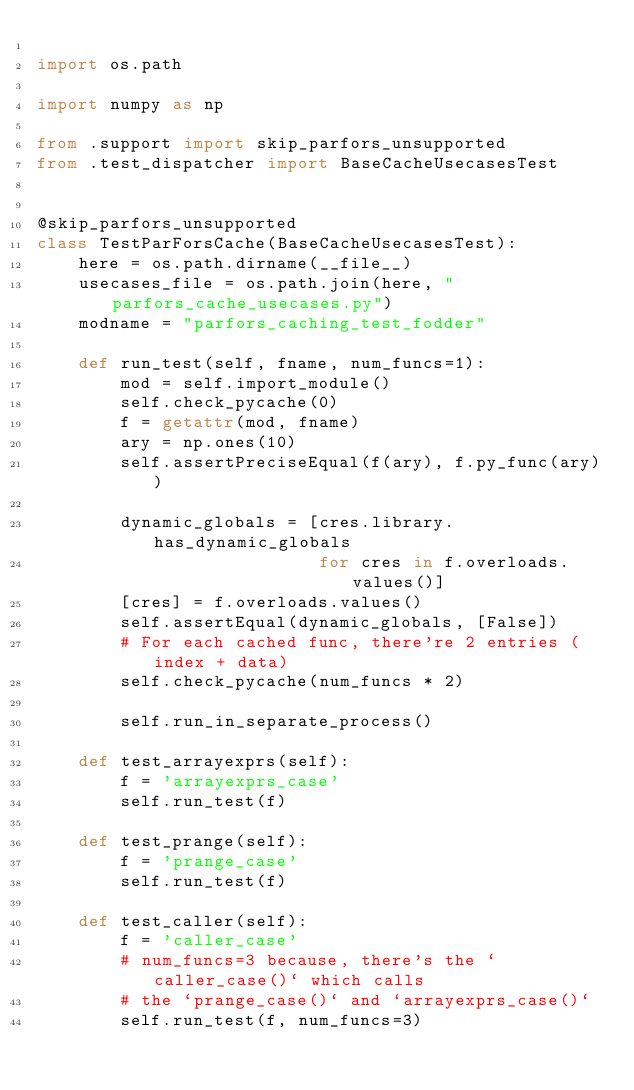<code> <loc_0><loc_0><loc_500><loc_500><_Python_>
import os.path

import numpy as np

from .support import skip_parfors_unsupported
from .test_dispatcher import BaseCacheUsecasesTest


@skip_parfors_unsupported
class TestParForsCache(BaseCacheUsecasesTest):
    here = os.path.dirname(__file__)
    usecases_file = os.path.join(here, "parfors_cache_usecases.py")
    modname = "parfors_caching_test_fodder"

    def run_test(self, fname, num_funcs=1):
        mod = self.import_module()
        self.check_pycache(0)
        f = getattr(mod, fname)
        ary = np.ones(10)
        self.assertPreciseEqual(f(ary), f.py_func(ary))

        dynamic_globals = [cres.library.has_dynamic_globals
                           for cres in f.overloads.values()]
        [cres] = f.overloads.values()
        self.assertEqual(dynamic_globals, [False])
        # For each cached func, there're 2 entries (index + data)
        self.check_pycache(num_funcs * 2)

        self.run_in_separate_process()

    def test_arrayexprs(self):
        f = 'arrayexprs_case'
        self.run_test(f)

    def test_prange(self):
        f = 'prange_case'
        self.run_test(f)

    def test_caller(self):
        f = 'caller_case'
        # num_funcs=3 because, there's the `caller_case()` which calls
        # the `prange_case()` and `arrayexprs_case()`
        self.run_test(f, num_funcs=3)
</code> 